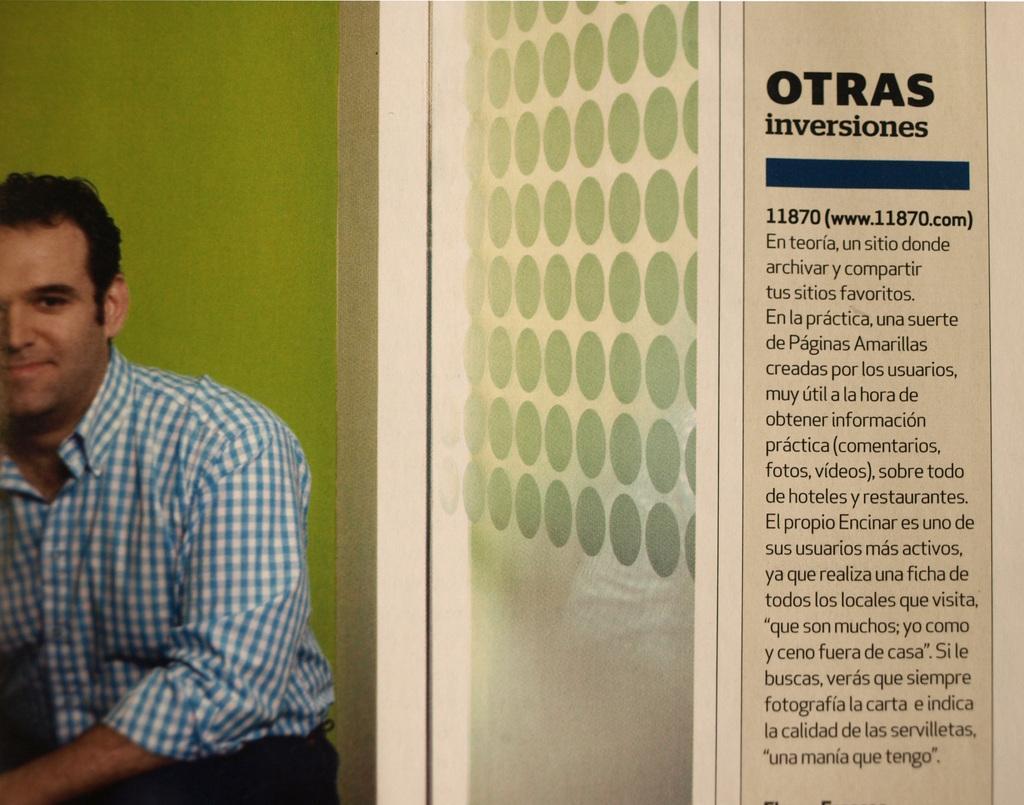Could you give a brief overview of what you see in this image? On the right side of the image we can see text. On the left side of the image we can see wall and person. 